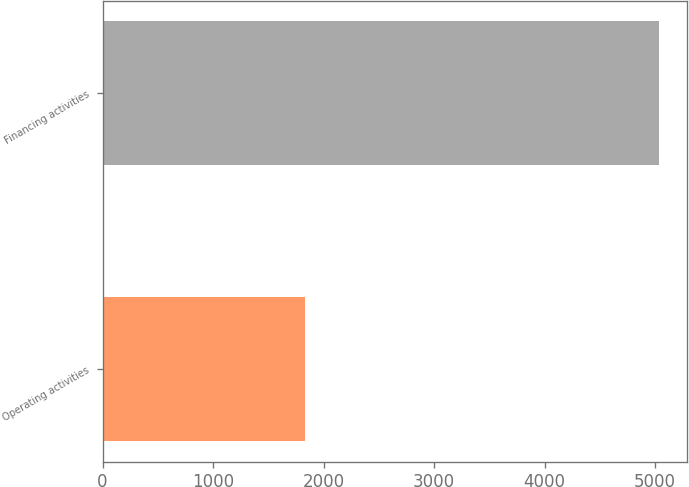Convert chart to OTSL. <chart><loc_0><loc_0><loc_500><loc_500><bar_chart><fcel>Operating activities<fcel>Financing activities<nl><fcel>1835<fcel>5036<nl></chart> 